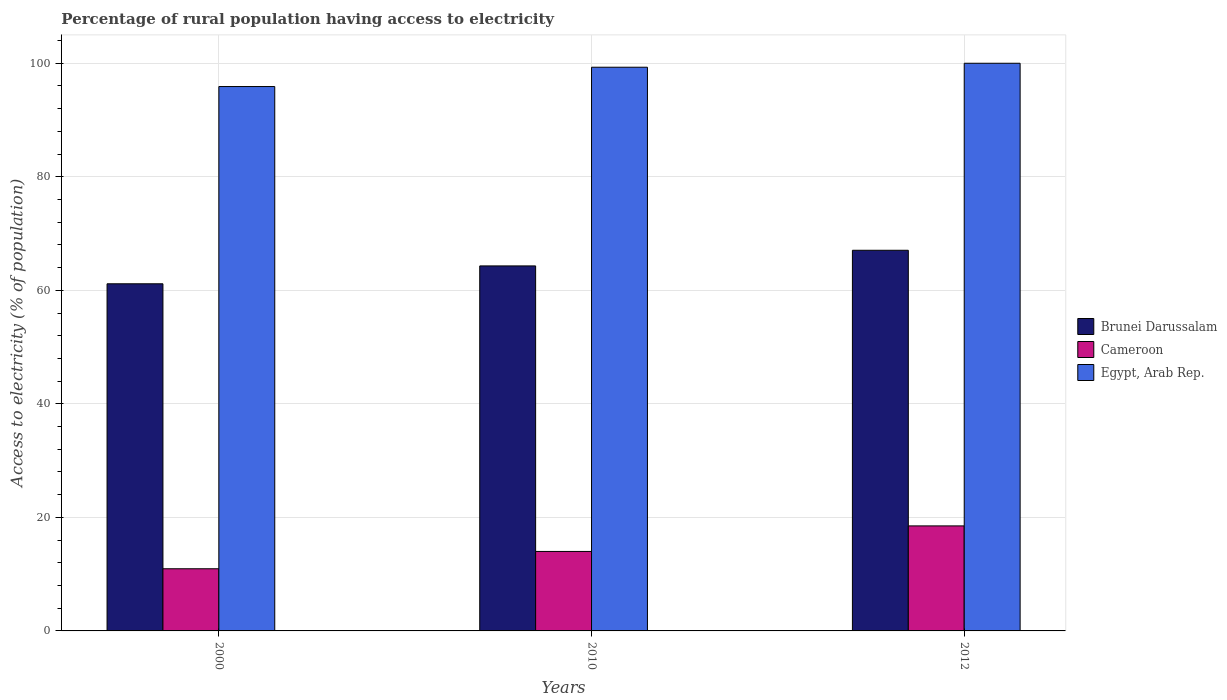How many different coloured bars are there?
Offer a very short reply. 3. How many bars are there on the 2nd tick from the left?
Provide a short and direct response. 3. What is the percentage of rural population having access to electricity in Cameroon in 2000?
Ensure brevity in your answer.  10.95. Across all years, what is the maximum percentage of rural population having access to electricity in Brunei Darussalam?
Your answer should be compact. 67.05. Across all years, what is the minimum percentage of rural population having access to electricity in Egypt, Arab Rep.?
Provide a succinct answer. 95.9. In which year was the percentage of rural population having access to electricity in Egypt, Arab Rep. maximum?
Offer a terse response. 2012. In which year was the percentage of rural population having access to electricity in Egypt, Arab Rep. minimum?
Make the answer very short. 2000. What is the total percentage of rural population having access to electricity in Brunei Darussalam in the graph?
Your answer should be very brief. 192.51. What is the difference between the percentage of rural population having access to electricity in Cameroon in 2000 and that in 2010?
Keep it short and to the point. -3.05. What is the difference between the percentage of rural population having access to electricity in Cameroon in 2000 and the percentage of rural population having access to electricity in Egypt, Arab Rep. in 2010?
Offer a terse response. -88.35. What is the average percentage of rural population having access to electricity in Egypt, Arab Rep. per year?
Provide a succinct answer. 98.4. In the year 2010, what is the difference between the percentage of rural population having access to electricity in Brunei Darussalam and percentage of rural population having access to electricity in Cameroon?
Offer a terse response. 50.3. In how many years, is the percentage of rural population having access to electricity in Brunei Darussalam greater than 52 %?
Ensure brevity in your answer.  3. What is the ratio of the percentage of rural population having access to electricity in Cameroon in 2000 to that in 2012?
Your answer should be compact. 0.59. Is the percentage of rural population having access to electricity in Brunei Darussalam in 2000 less than that in 2012?
Provide a succinct answer. Yes. What is the difference between the highest and the second highest percentage of rural population having access to electricity in Egypt, Arab Rep.?
Make the answer very short. 0.7. What is the difference between the highest and the lowest percentage of rural population having access to electricity in Cameroon?
Offer a very short reply. 7.55. Is the sum of the percentage of rural population having access to electricity in Cameroon in 2010 and 2012 greater than the maximum percentage of rural population having access to electricity in Egypt, Arab Rep. across all years?
Give a very brief answer. No. What does the 3rd bar from the left in 2000 represents?
Give a very brief answer. Egypt, Arab Rep. What does the 3rd bar from the right in 2012 represents?
Give a very brief answer. Brunei Darussalam. Is it the case that in every year, the sum of the percentage of rural population having access to electricity in Egypt, Arab Rep. and percentage of rural population having access to electricity in Brunei Darussalam is greater than the percentage of rural population having access to electricity in Cameroon?
Your answer should be very brief. Yes. How many years are there in the graph?
Your answer should be compact. 3. How many legend labels are there?
Offer a terse response. 3. What is the title of the graph?
Your answer should be compact. Percentage of rural population having access to electricity. Does "Comoros" appear as one of the legend labels in the graph?
Make the answer very short. No. What is the label or title of the Y-axis?
Give a very brief answer. Access to electricity (% of population). What is the Access to electricity (% of population) in Brunei Darussalam in 2000?
Provide a succinct answer. 61.15. What is the Access to electricity (% of population) in Cameroon in 2000?
Your answer should be compact. 10.95. What is the Access to electricity (% of population) of Egypt, Arab Rep. in 2000?
Ensure brevity in your answer.  95.9. What is the Access to electricity (% of population) of Brunei Darussalam in 2010?
Your response must be concise. 64.3. What is the Access to electricity (% of population) in Egypt, Arab Rep. in 2010?
Your answer should be compact. 99.3. What is the Access to electricity (% of population) in Brunei Darussalam in 2012?
Offer a very short reply. 67.05. What is the Access to electricity (% of population) in Cameroon in 2012?
Your answer should be very brief. 18.5. Across all years, what is the maximum Access to electricity (% of population) in Brunei Darussalam?
Your answer should be very brief. 67.05. Across all years, what is the maximum Access to electricity (% of population) in Cameroon?
Make the answer very short. 18.5. Across all years, what is the minimum Access to electricity (% of population) of Brunei Darussalam?
Give a very brief answer. 61.15. Across all years, what is the minimum Access to electricity (% of population) of Cameroon?
Provide a short and direct response. 10.95. Across all years, what is the minimum Access to electricity (% of population) of Egypt, Arab Rep.?
Offer a terse response. 95.9. What is the total Access to electricity (% of population) in Brunei Darussalam in the graph?
Your response must be concise. 192.51. What is the total Access to electricity (% of population) of Cameroon in the graph?
Ensure brevity in your answer.  43.45. What is the total Access to electricity (% of population) of Egypt, Arab Rep. in the graph?
Keep it short and to the point. 295.2. What is the difference between the Access to electricity (% of population) of Brunei Darussalam in 2000 and that in 2010?
Your answer should be very brief. -3.15. What is the difference between the Access to electricity (% of population) in Cameroon in 2000 and that in 2010?
Provide a succinct answer. -3.05. What is the difference between the Access to electricity (% of population) of Brunei Darussalam in 2000 and that in 2012?
Give a very brief answer. -5.9. What is the difference between the Access to electricity (% of population) in Cameroon in 2000 and that in 2012?
Give a very brief answer. -7.55. What is the difference between the Access to electricity (% of population) in Brunei Darussalam in 2010 and that in 2012?
Provide a short and direct response. -2.75. What is the difference between the Access to electricity (% of population) in Brunei Darussalam in 2000 and the Access to electricity (% of population) in Cameroon in 2010?
Give a very brief answer. 47.15. What is the difference between the Access to electricity (% of population) in Brunei Darussalam in 2000 and the Access to electricity (% of population) in Egypt, Arab Rep. in 2010?
Keep it short and to the point. -38.15. What is the difference between the Access to electricity (% of population) in Cameroon in 2000 and the Access to electricity (% of population) in Egypt, Arab Rep. in 2010?
Offer a terse response. -88.35. What is the difference between the Access to electricity (% of population) in Brunei Darussalam in 2000 and the Access to electricity (% of population) in Cameroon in 2012?
Provide a short and direct response. 42.65. What is the difference between the Access to electricity (% of population) of Brunei Darussalam in 2000 and the Access to electricity (% of population) of Egypt, Arab Rep. in 2012?
Give a very brief answer. -38.85. What is the difference between the Access to electricity (% of population) of Cameroon in 2000 and the Access to electricity (% of population) of Egypt, Arab Rep. in 2012?
Your answer should be very brief. -89.05. What is the difference between the Access to electricity (% of population) in Brunei Darussalam in 2010 and the Access to electricity (% of population) in Cameroon in 2012?
Provide a short and direct response. 45.8. What is the difference between the Access to electricity (% of population) of Brunei Darussalam in 2010 and the Access to electricity (% of population) of Egypt, Arab Rep. in 2012?
Make the answer very short. -35.7. What is the difference between the Access to electricity (% of population) in Cameroon in 2010 and the Access to electricity (% of population) in Egypt, Arab Rep. in 2012?
Your response must be concise. -86. What is the average Access to electricity (% of population) of Brunei Darussalam per year?
Ensure brevity in your answer.  64.17. What is the average Access to electricity (% of population) of Cameroon per year?
Provide a short and direct response. 14.48. What is the average Access to electricity (% of population) of Egypt, Arab Rep. per year?
Offer a very short reply. 98.4. In the year 2000, what is the difference between the Access to electricity (% of population) in Brunei Darussalam and Access to electricity (% of population) in Cameroon?
Provide a succinct answer. 50.2. In the year 2000, what is the difference between the Access to electricity (% of population) of Brunei Darussalam and Access to electricity (% of population) of Egypt, Arab Rep.?
Offer a very short reply. -34.75. In the year 2000, what is the difference between the Access to electricity (% of population) in Cameroon and Access to electricity (% of population) in Egypt, Arab Rep.?
Your answer should be compact. -84.95. In the year 2010, what is the difference between the Access to electricity (% of population) in Brunei Darussalam and Access to electricity (% of population) in Cameroon?
Offer a terse response. 50.3. In the year 2010, what is the difference between the Access to electricity (% of population) of Brunei Darussalam and Access to electricity (% of population) of Egypt, Arab Rep.?
Your response must be concise. -35. In the year 2010, what is the difference between the Access to electricity (% of population) in Cameroon and Access to electricity (% of population) in Egypt, Arab Rep.?
Make the answer very short. -85.3. In the year 2012, what is the difference between the Access to electricity (% of population) of Brunei Darussalam and Access to electricity (% of population) of Cameroon?
Provide a short and direct response. 48.55. In the year 2012, what is the difference between the Access to electricity (% of population) of Brunei Darussalam and Access to electricity (% of population) of Egypt, Arab Rep.?
Your answer should be very brief. -32.95. In the year 2012, what is the difference between the Access to electricity (% of population) of Cameroon and Access to electricity (% of population) of Egypt, Arab Rep.?
Give a very brief answer. -81.5. What is the ratio of the Access to electricity (% of population) of Brunei Darussalam in 2000 to that in 2010?
Offer a very short reply. 0.95. What is the ratio of the Access to electricity (% of population) in Cameroon in 2000 to that in 2010?
Offer a terse response. 0.78. What is the ratio of the Access to electricity (% of population) of Egypt, Arab Rep. in 2000 to that in 2010?
Give a very brief answer. 0.97. What is the ratio of the Access to electricity (% of population) in Brunei Darussalam in 2000 to that in 2012?
Make the answer very short. 0.91. What is the ratio of the Access to electricity (% of population) in Cameroon in 2000 to that in 2012?
Your response must be concise. 0.59. What is the ratio of the Access to electricity (% of population) of Brunei Darussalam in 2010 to that in 2012?
Make the answer very short. 0.96. What is the ratio of the Access to electricity (% of population) of Cameroon in 2010 to that in 2012?
Provide a succinct answer. 0.76. What is the ratio of the Access to electricity (% of population) of Egypt, Arab Rep. in 2010 to that in 2012?
Keep it short and to the point. 0.99. What is the difference between the highest and the second highest Access to electricity (% of population) of Brunei Darussalam?
Provide a succinct answer. 2.75. What is the difference between the highest and the second highest Access to electricity (% of population) in Cameroon?
Give a very brief answer. 4.5. What is the difference between the highest and the second highest Access to electricity (% of population) of Egypt, Arab Rep.?
Ensure brevity in your answer.  0.7. What is the difference between the highest and the lowest Access to electricity (% of population) of Brunei Darussalam?
Ensure brevity in your answer.  5.9. What is the difference between the highest and the lowest Access to electricity (% of population) in Cameroon?
Offer a terse response. 7.55. What is the difference between the highest and the lowest Access to electricity (% of population) in Egypt, Arab Rep.?
Offer a very short reply. 4.1. 